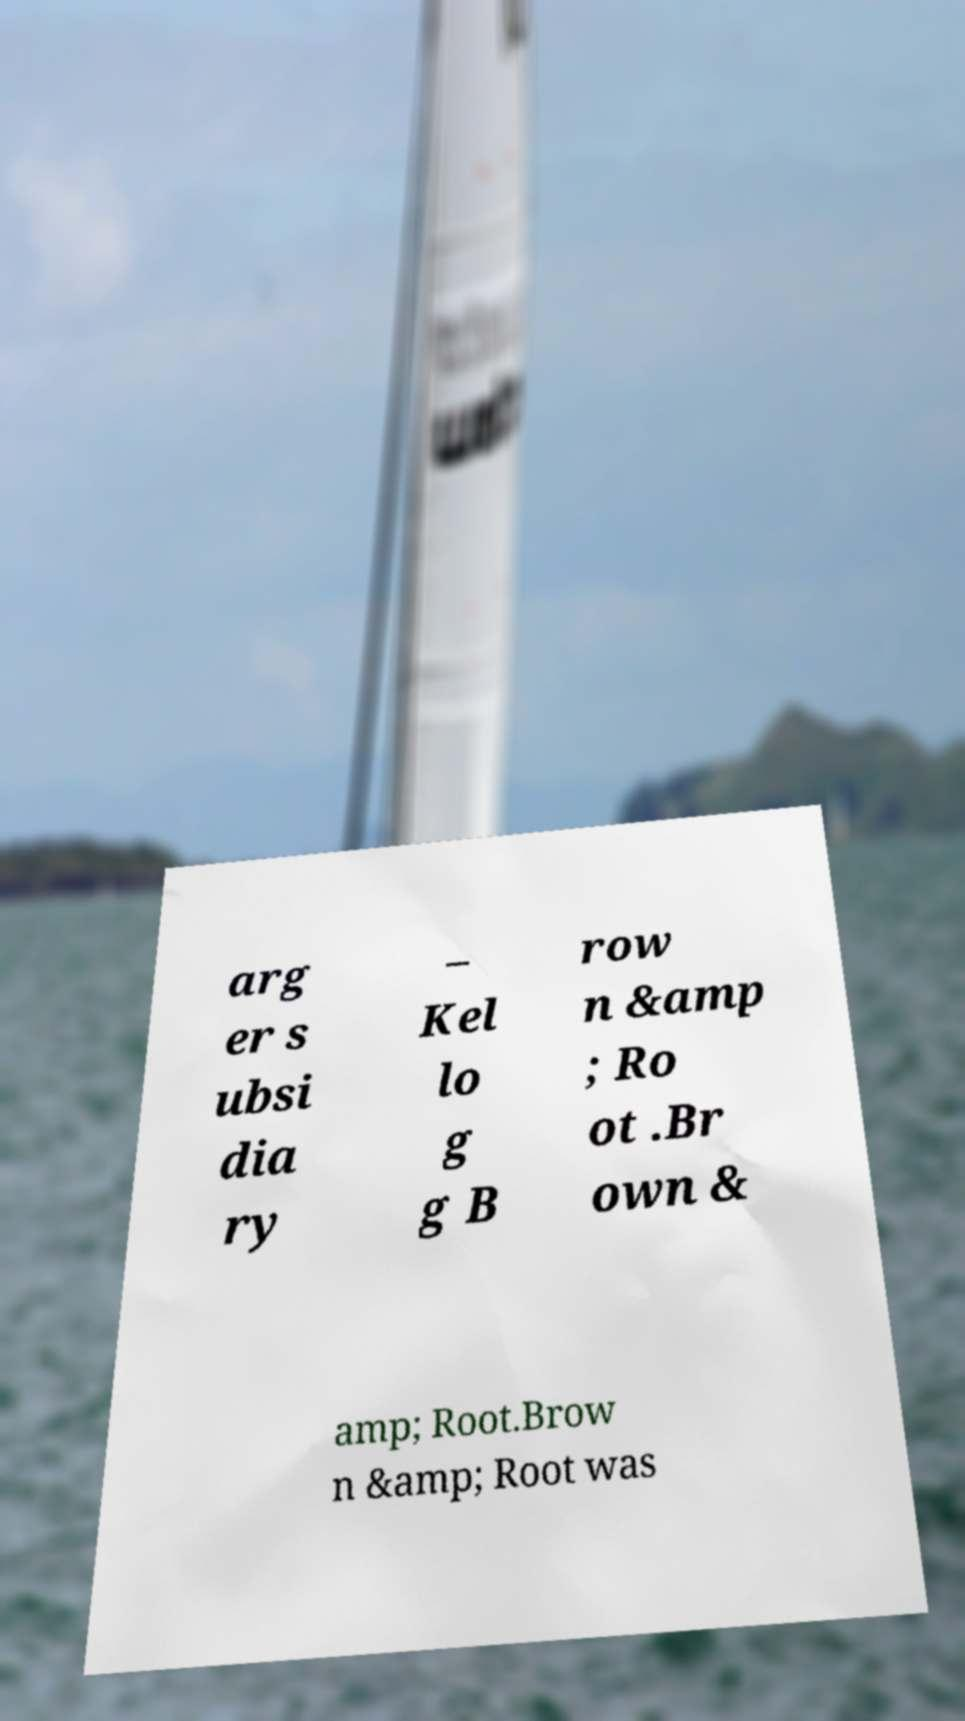I need the written content from this picture converted into text. Can you do that? arg er s ubsi dia ry – Kel lo g g B row n &amp ; Ro ot .Br own & amp; Root.Brow n &amp; Root was 